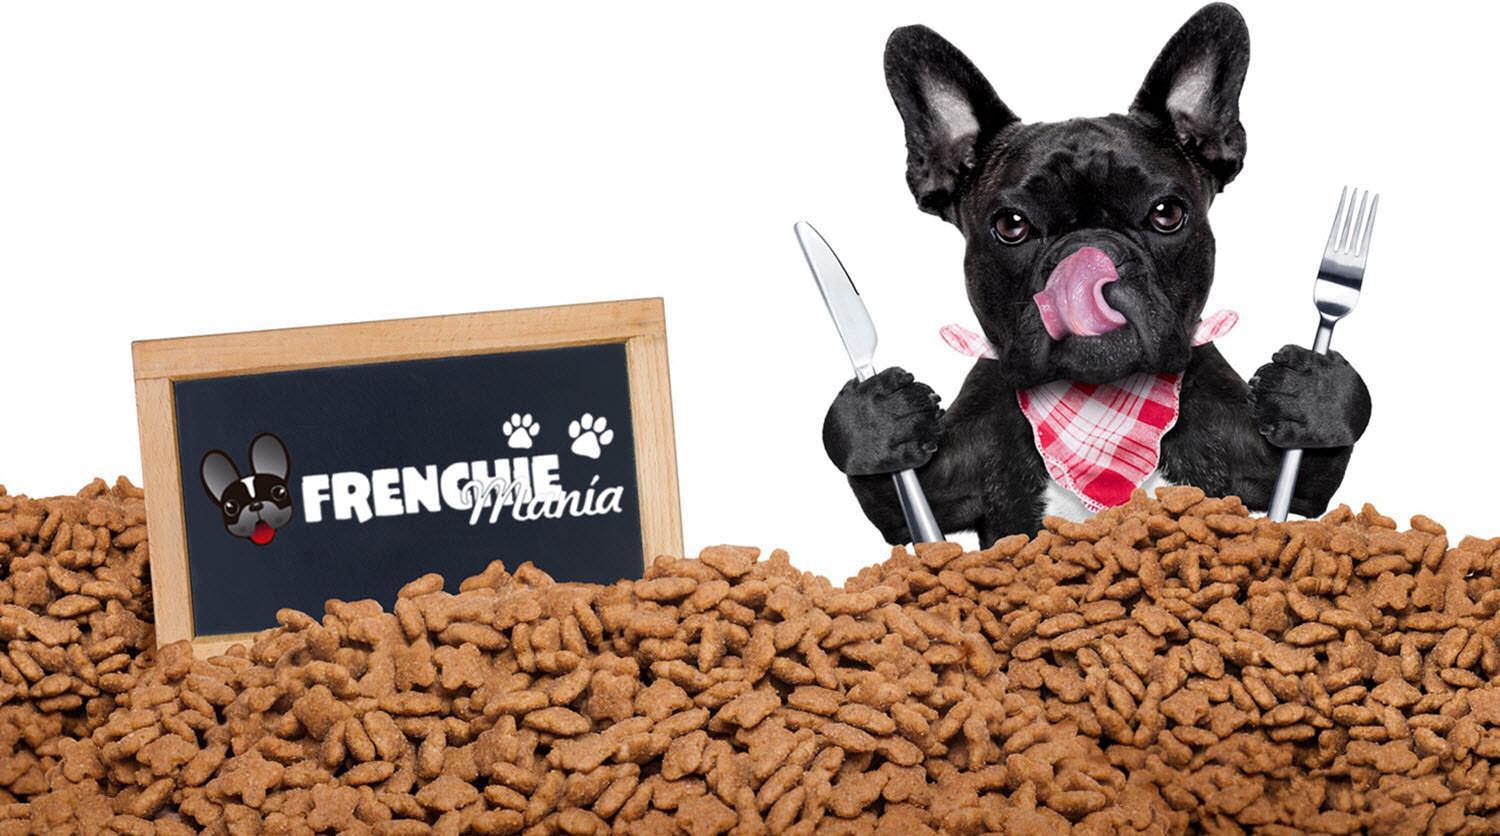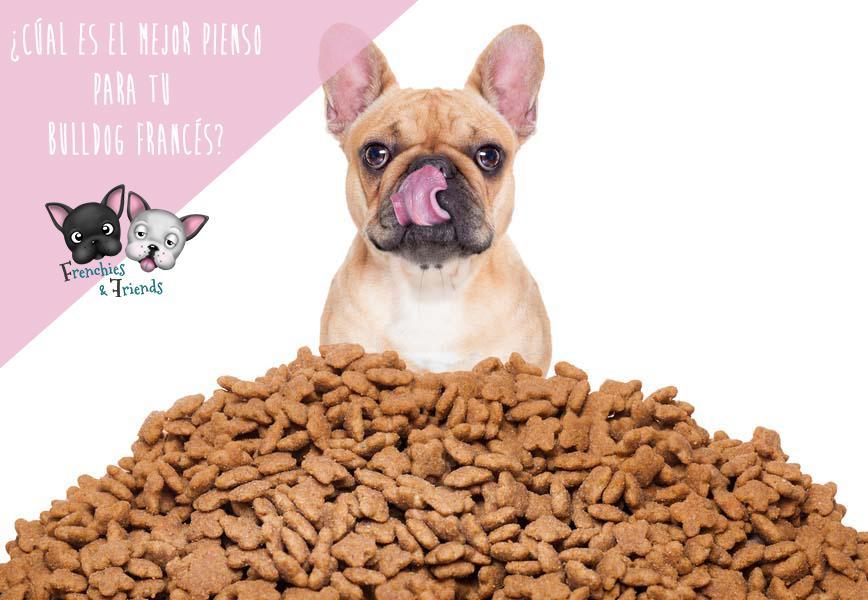The first image is the image on the left, the second image is the image on the right. Analyze the images presented: Is the assertion "There is a dog sitting in a pile of dog treats." valid? Answer yes or no. Yes. The first image is the image on the left, the second image is the image on the right. For the images displayed, is the sentence "One dog is wearing a bib." factually correct? Answer yes or no. Yes. 